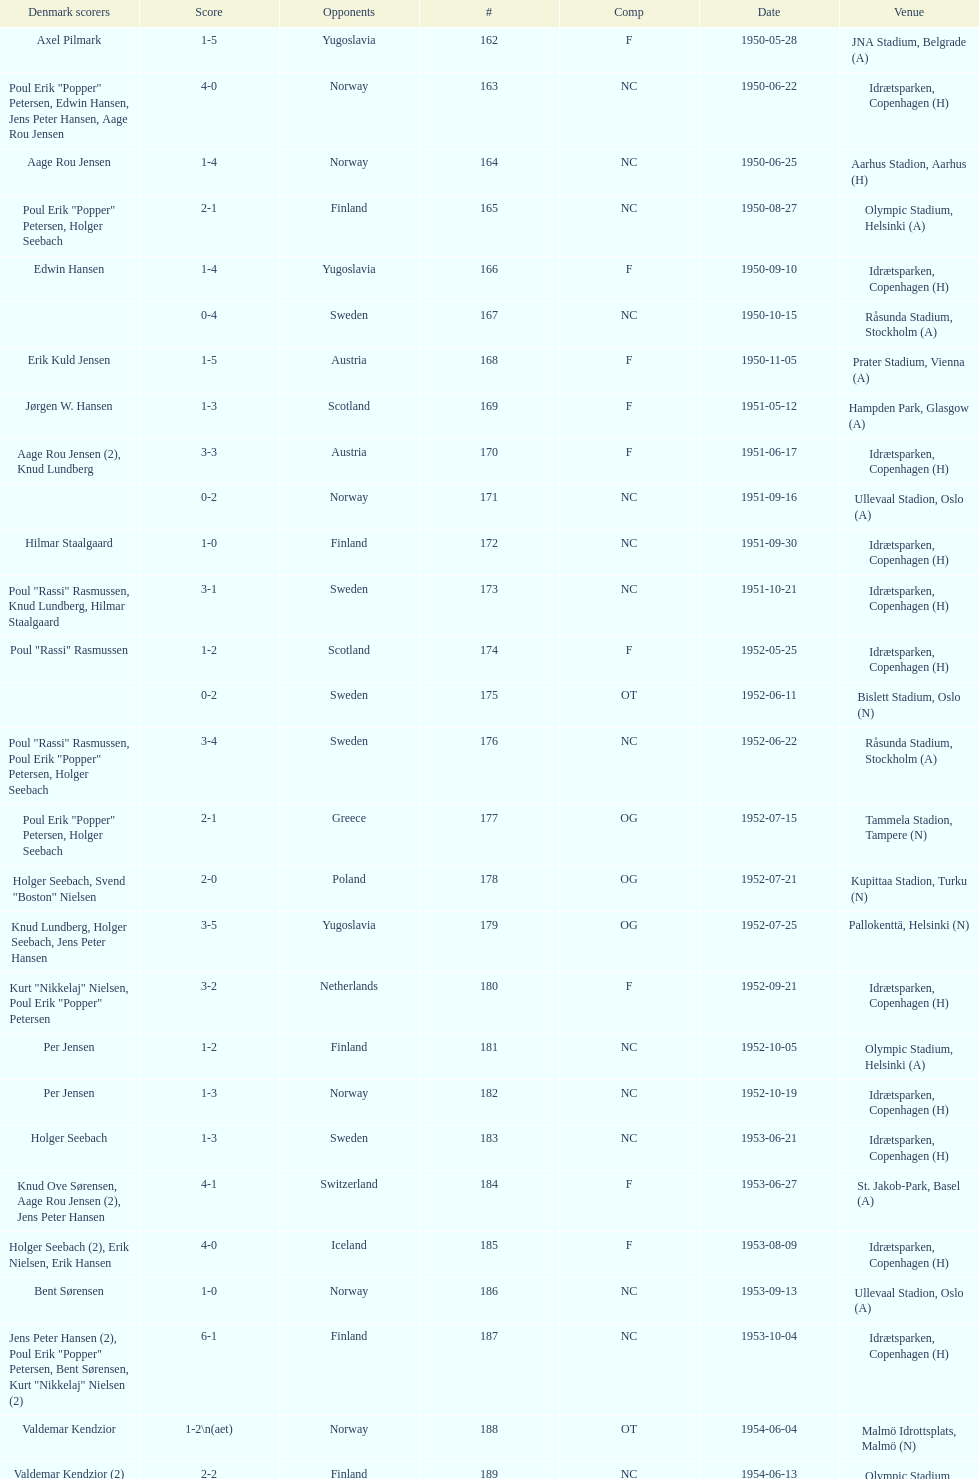Can you give me this table as a dict? {'header': ['Denmark scorers', 'Score', 'Opponents', '#', 'Comp', 'Date', 'Venue'], 'rows': [['Axel Pilmark', '1-5', 'Yugoslavia', '162', 'F', '1950-05-28', 'JNA Stadium, Belgrade (A)'], ['Poul Erik "Popper" Petersen, Edwin Hansen, Jens Peter Hansen, Aage Rou Jensen', '4-0', 'Norway', '163', 'NC', '1950-06-22', 'Idrætsparken, Copenhagen (H)'], ['Aage Rou Jensen', '1-4', 'Norway', '164', 'NC', '1950-06-25', 'Aarhus Stadion, Aarhus (H)'], ['Poul Erik "Popper" Petersen, Holger Seebach', '2-1', 'Finland', '165', 'NC', '1950-08-27', 'Olympic Stadium, Helsinki (A)'], ['Edwin Hansen', '1-4', 'Yugoslavia', '166', 'F', '1950-09-10', 'Idrætsparken, Copenhagen (H)'], ['', '0-4', 'Sweden', '167', 'NC', '1950-10-15', 'Råsunda Stadium, Stockholm (A)'], ['Erik Kuld Jensen', '1-5', 'Austria', '168', 'F', '1950-11-05', 'Prater Stadium, Vienna (A)'], ['Jørgen W. Hansen', '1-3', 'Scotland', '169', 'F', '1951-05-12', 'Hampden Park, Glasgow (A)'], ['Aage Rou Jensen (2), Knud Lundberg', '3-3', 'Austria', '170', 'F', '1951-06-17', 'Idrætsparken, Copenhagen (H)'], ['', '0-2', 'Norway', '171', 'NC', '1951-09-16', 'Ullevaal Stadion, Oslo (A)'], ['Hilmar Staalgaard', '1-0', 'Finland', '172', 'NC', '1951-09-30', 'Idrætsparken, Copenhagen (H)'], ['Poul "Rassi" Rasmussen, Knud Lundberg, Hilmar Staalgaard', '3-1', 'Sweden', '173', 'NC', '1951-10-21', 'Idrætsparken, Copenhagen (H)'], ['Poul "Rassi" Rasmussen', '1-2', 'Scotland', '174', 'F', '1952-05-25', 'Idrætsparken, Copenhagen (H)'], ['', '0-2', 'Sweden', '175', 'OT', '1952-06-11', 'Bislett Stadium, Oslo (N)'], ['Poul "Rassi" Rasmussen, Poul Erik "Popper" Petersen, Holger Seebach', '3-4', 'Sweden', '176', 'NC', '1952-06-22', 'Råsunda Stadium, Stockholm (A)'], ['Poul Erik "Popper" Petersen, Holger Seebach', '2-1', 'Greece', '177', 'OG', '1952-07-15', 'Tammela Stadion, Tampere (N)'], ['Holger Seebach, Svend "Boston" Nielsen', '2-0', 'Poland', '178', 'OG', '1952-07-21', 'Kupittaa Stadion, Turku (N)'], ['Knud Lundberg, Holger Seebach, Jens Peter Hansen', '3-5', 'Yugoslavia', '179', 'OG', '1952-07-25', 'Pallokenttä, Helsinki (N)'], ['Kurt "Nikkelaj" Nielsen, Poul Erik "Popper" Petersen', '3-2', 'Netherlands', '180', 'F', '1952-09-21', 'Idrætsparken, Copenhagen (H)'], ['Per Jensen', '1-2', 'Finland', '181', 'NC', '1952-10-05', 'Olympic Stadium, Helsinki (A)'], ['Per Jensen', '1-3', 'Norway', '182', 'NC', '1952-10-19', 'Idrætsparken, Copenhagen (H)'], ['Holger Seebach', '1-3', 'Sweden', '183', 'NC', '1953-06-21', 'Idrætsparken, Copenhagen (H)'], ['Knud Ove Sørensen, Aage Rou Jensen (2), Jens Peter Hansen', '4-1', 'Switzerland', '184', 'F', '1953-06-27', 'St. Jakob-Park, Basel (A)'], ['Holger Seebach (2), Erik Nielsen, Erik Hansen', '4-0', 'Iceland', '185', 'F', '1953-08-09', 'Idrætsparken, Copenhagen (H)'], ['Bent Sørensen', '1-0', 'Norway', '186', 'NC', '1953-09-13', 'Ullevaal Stadion, Oslo (A)'], ['Jens Peter Hansen (2), Poul Erik "Popper" Petersen, Bent Sørensen, Kurt "Nikkelaj" Nielsen (2)', '6-1', 'Finland', '187', 'NC', '1953-10-04', 'Idrætsparken, Copenhagen (H)'], ['Valdemar Kendzior', '1-2\\n(aet)', 'Norway', '188', 'OT', '1954-06-04', 'Malmö Idrottsplats, Malmö (N)'], ['Valdemar Kendzior (2)', '2-2', 'Finland', '189', 'NC', '1954-06-13', 'Olympic Stadium, Helsinki (A)'], ['Jørgen Olesen', '1-1', 'Switzerland', '190', 'F', '1954-09-19', 'Idrætsparken, Copenhagen (H)'], ['Jens Peter Hansen, Bent Sørensen', '2-5', 'Sweden', '191', 'NC', '1954-10-10', 'Råsunda Stadium, Stockholm (A)'], ['', '0-1', 'Norway', '192', 'NC', '1954-10-31', 'Idrætsparken, Copenhagen (H)'], ['Vagn Birkeland', '1-1', 'Netherlands', '193', 'F', '1955-03-13', 'Olympic Stadium, Amsterdam (A)'], ['', '0-6', 'Hungary', '194', 'F', '1955-05-15', 'Idrætsparken, Copenhagen (H)'], ['Jens Peter Hansen (2)', '2-1', 'Finland', '195', 'NC', '1955-06-19', 'Idrætsparken, Copenhagen (H)'], ['Aage Rou Jensen, Jens Peter Hansen, Poul Pedersen (2)', '4-0', 'Iceland', '196', 'F', '1955-06-03', 'Melavollur, Reykjavík (A)'], ['Jørgen Jacobsen', '1-1', 'Norway', '197', 'NC', '1955-09-11', 'Ullevaal Stadion, Oslo (A)'], ['Knud Lundberg', '1-5', 'England', '198', 'NC', '1955-10-02', 'Idrætsparken, Copenhagen (H)'], ['Ove Andersen (2), Knud Lundberg', '3-3', 'Sweden', '199', 'NC', '1955-10-16', 'Idrætsparken, Copenhagen (H)'], ['Knud Lundberg', '1-5', 'USSR', '200', 'F', '1956-05-23', 'Dynamo Stadium, Moscow (A)'], ['Knud Lundberg, Poul Pedersen', '2-3', 'Norway', '201', 'NC', '1956-06-24', 'Idrætsparken, Copenhagen (H)'], ['Ove Andersen, Aage Rou Jensen', '2-5', 'USSR', '202', 'F', '1956-07-01', 'Idrætsparken, Copenhagen (H)'], ['Poul Pedersen, Jørgen Hansen, Ove Andersen (2)', '4-0', 'Finland', '203', 'NC', '1956-09-16', 'Olympic Stadium, Helsinki (A)'], ['Aage Rou Jensen', '1-2', 'Republic of Ireland', '204', 'WCQ', '1956-10-03', 'Dalymount Park, Dublin (A)'], ['Jens Peter Hansen', '1-1', 'Sweden', '205', 'NC', '1956-10-21', 'Råsunda Stadium, Stockholm (A)'], ['Jørgen Olesen, Knud Lundberg', '2-2', 'Netherlands', '206', 'F', '1956-11-04', 'Idrætsparken, Copenhagen (H)'], ['Ove Bech Nielsen (2)', '2-5', 'England', '207', 'WCQ', '1956-12-05', 'Molineux, Wolverhampton (A)'], ['John Jensen', '1-4', 'England', '208', 'WCQ', '1957-05-15', 'Idrætsparken, Copenhagen (H)'], ['Aage Rou Jensen', '1-1', 'Bulgaria', '209', 'F', '1957-05-26', 'Idrætsparken, Copenhagen (H)'], ['', '0-2', 'Finland', '210', 'OT', '1957-06-18', 'Olympic Stadium, Helsinki (A)'], ['Egon Jensen, Jørgen Hansen', '2-0', 'Norway', '211', 'OT', '1957-06-19', 'Tammela Stadion, Tampere (N)'], ['Jens Peter Hansen', '1-2', 'Sweden', '212', 'NC', '1957-06-30', 'Idrætsparken, Copenhagen (H)'], ['Egon Jensen (3), Poul Pedersen, Jens Peter Hansen (2)', '6-2', 'Iceland', '213', 'OT', '1957-07-10', 'Laugardalsvöllur, Reykjavík (A)'], ['Poul Pedersen, Peder Kjær', '2-2', 'Norway', '214', 'NC', '1957-09-22', 'Ullevaal Stadion, Oslo (A)'], ['', '0-2', 'Republic of Ireland', '215', 'WCQ', '1957-10-02', 'Idrætsparken, Copenhagen (H)'], ['Finn Alfred Hansen, Ove Bech Nielsen, Mogens Machon', '3-0', 'Finland', '216', 'NC', '1957-10-13', 'Idrætsparken, Copenhagen (H)'], ['Poul Pedersen, Henning Enoksen (2)', '3-2', 'Curaçao', '217', 'F', '1958-05-15', 'Aarhus Stadion, Aarhus (H)'], ['Jørn Sørensen, Poul Pedersen (2)', '3-2', 'Poland', '218', 'F', '1958-05-25', 'Idrætsparken, Copenhagen (H)'], ['Poul Pedersen', '1-2', 'Norway', '219', 'NC', '1958-06-29', 'Idrætsparken, Copenhagen (H)'], ['Poul Pedersen, Mogens Machon, John Danielsen (2)', '4-1', 'Finland', '220', 'NC', '1958-09-14', 'Olympic Stadium, Helsinki (A)'], ['Henning Enoksen', '1-1', 'West Germany', '221', 'F', '1958-09-24', 'Idrætsparken, Copenhagen (H)'], ['Henning Enoksen', '1-5', 'Netherlands', '222', 'F', '1958-10-15', 'Idrætsparken, Copenhagen (H)'], ['Ole Madsen (2), Henning Enoksen, Jørn Sørensen', '4-4', 'Sweden', '223', 'NC', '1958-10-26', 'Råsunda Stadium, Stockholm (A)'], ['', '0-6', 'Sweden', '224', 'NC', '1959-06-21', 'Idrætsparken, Copenhagen (H)'], ['Jens Peter Hansen (2), Ole Madsen (2)', '4-2', 'Iceland', '225', 'OGQ', '1959-06-26', 'Laugardalsvöllur, Reykjavík (A)'], ['Henning Enoksen, Ole Madsen', '2-1', 'Norway', '226', 'OGQ', '1959-07-02', 'Idrætsparken, Copenhagen (H)'], ['Henning Enoksen', '1-1', 'Iceland', '227', 'OGQ', '1959-08-18', 'Idrætsparken, Copenhagen (H)'], ['Harald Nielsen, Henning Enoksen (2), Poul Pedersen', '4-2', 'Norway', '228', 'OGQ\\nNC', '1959-09-13', 'Ullevaal Stadion, Oslo (A)'], ['Poul Pedersen, Bent Hansen', '2-2', 'Czechoslovakia', '229', 'ENQ', '1959-09-23', 'Idrætsparken, Copenhagen (H)'], ['Harald Nielsen (3), John Kramer', '4-0', 'Finland', '230', 'NC', '1959-10-04', 'Idrætsparken, Copenhagen (H)'], ['John Kramer', '1-5', 'Czechoslovakia', '231', 'ENQ', '1959-10-18', 'Stadion Za Lužánkami, Brno (A)'], ['Henning Enoksen (2), Poul Pedersen', '3-1', 'Greece', '232', 'F', '1959-12-02', 'Olympic Stadium, Athens (A)'], ['Henning Enoksen', '1-2', 'Bulgaria', '233', 'F', '1959-12-06', 'Vasil Levski National Stadium, Sofia (A)']]} How many instances were there when poland was the rival? 2. 